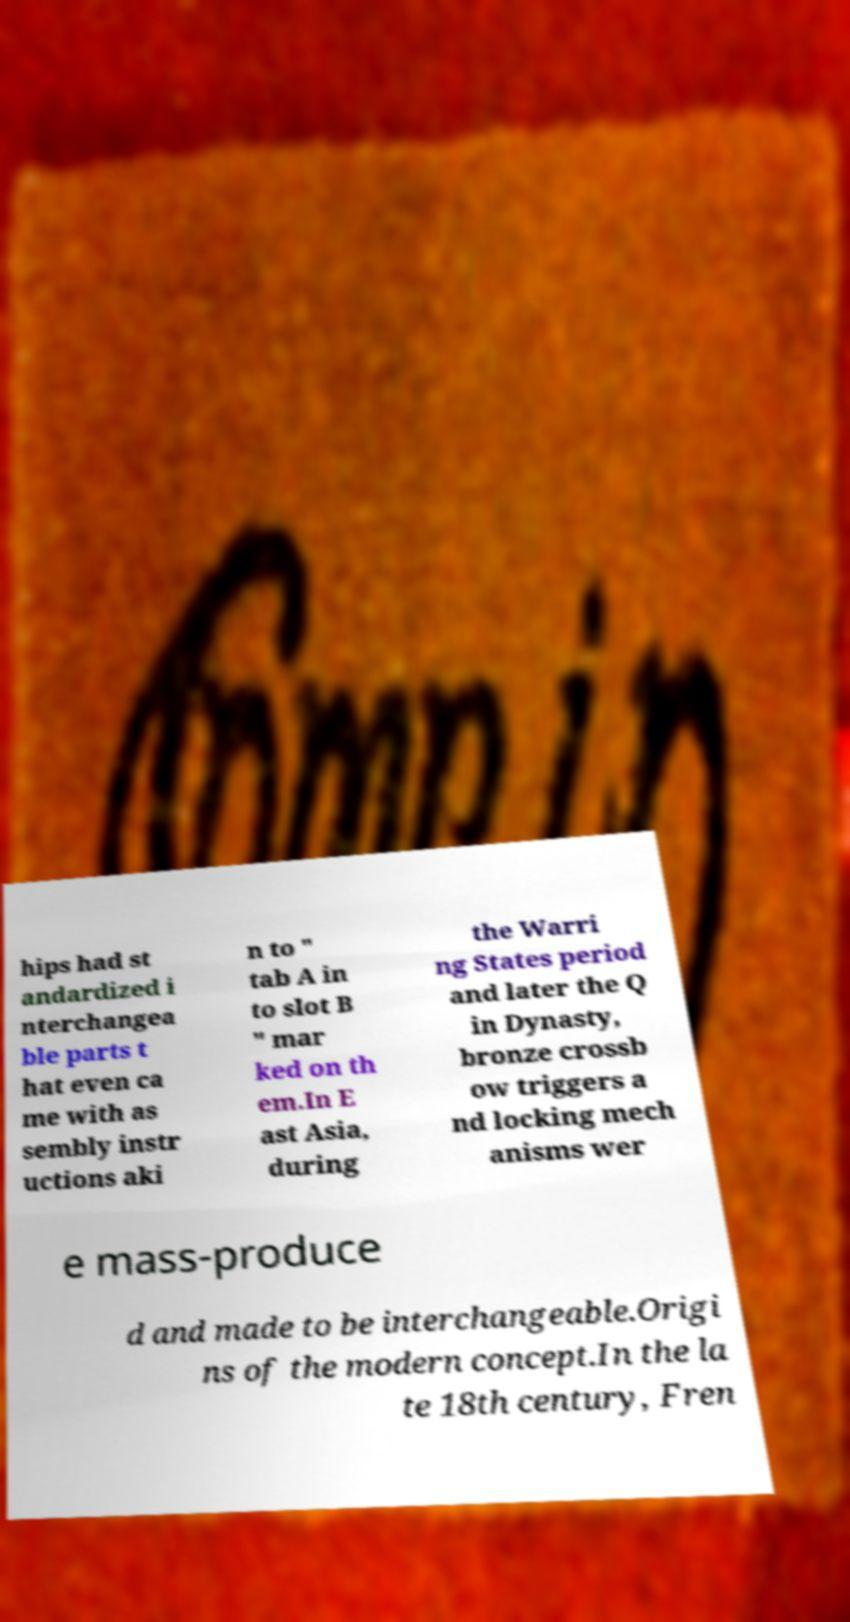There's text embedded in this image that I need extracted. Can you transcribe it verbatim? hips had st andardized i nterchangea ble parts t hat even ca me with as sembly instr uctions aki n to " tab A in to slot B " mar ked on th em.In E ast Asia, during the Warri ng States period and later the Q in Dynasty, bronze crossb ow triggers a nd locking mech anisms wer e mass-produce d and made to be interchangeable.Origi ns of the modern concept.In the la te 18th century, Fren 